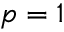<formula> <loc_0><loc_0><loc_500><loc_500>p = 1</formula> 